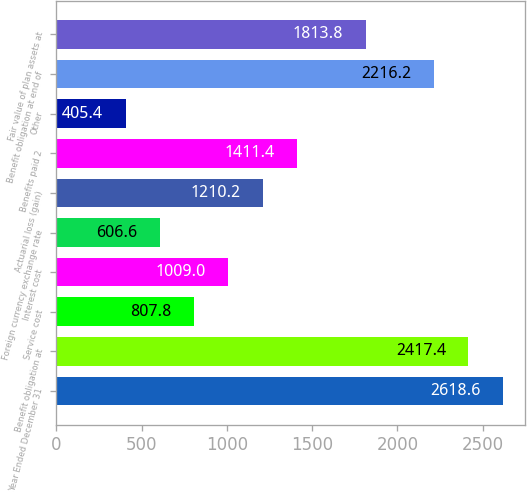Convert chart. <chart><loc_0><loc_0><loc_500><loc_500><bar_chart><fcel>Year Ended December 31<fcel>Benefit obligation at<fcel>Service cost<fcel>Interest cost<fcel>Foreign currency exchange rate<fcel>Actuarial loss (gain)<fcel>Benefits paid 2<fcel>Other<fcel>Benefit obligation at end of<fcel>Fair value of plan assets at<nl><fcel>2618.6<fcel>2417.4<fcel>807.8<fcel>1009<fcel>606.6<fcel>1210.2<fcel>1411.4<fcel>405.4<fcel>2216.2<fcel>1813.8<nl></chart> 